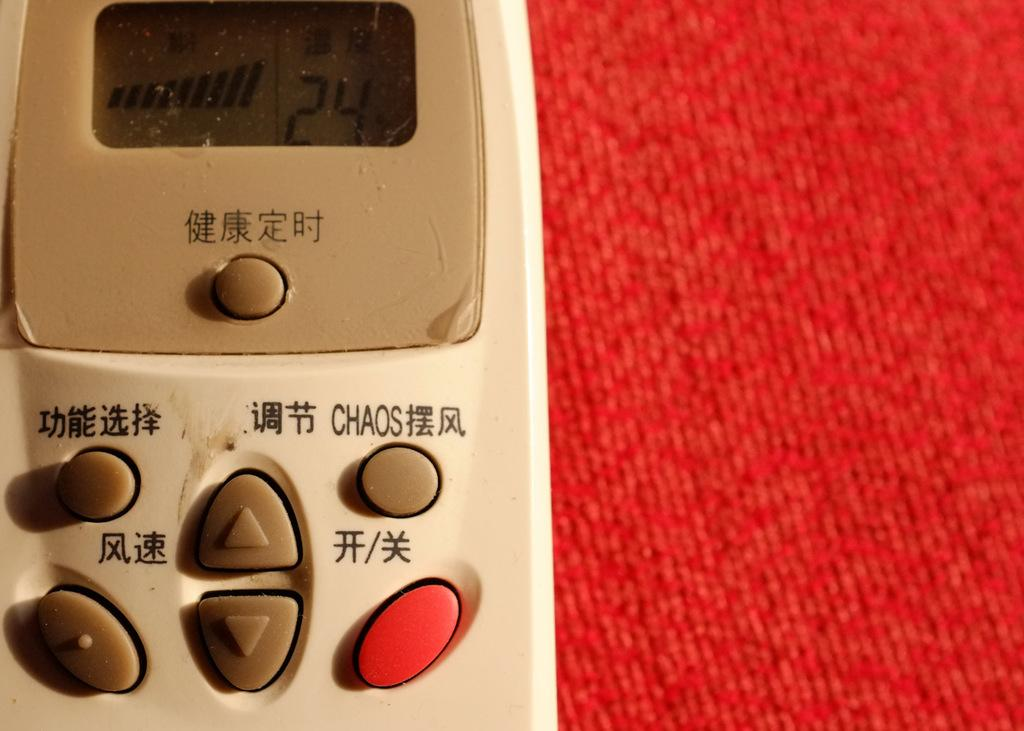<image>
Share a concise interpretation of the image provided. A remote that has Chinese letters on it and the word Chaos. 